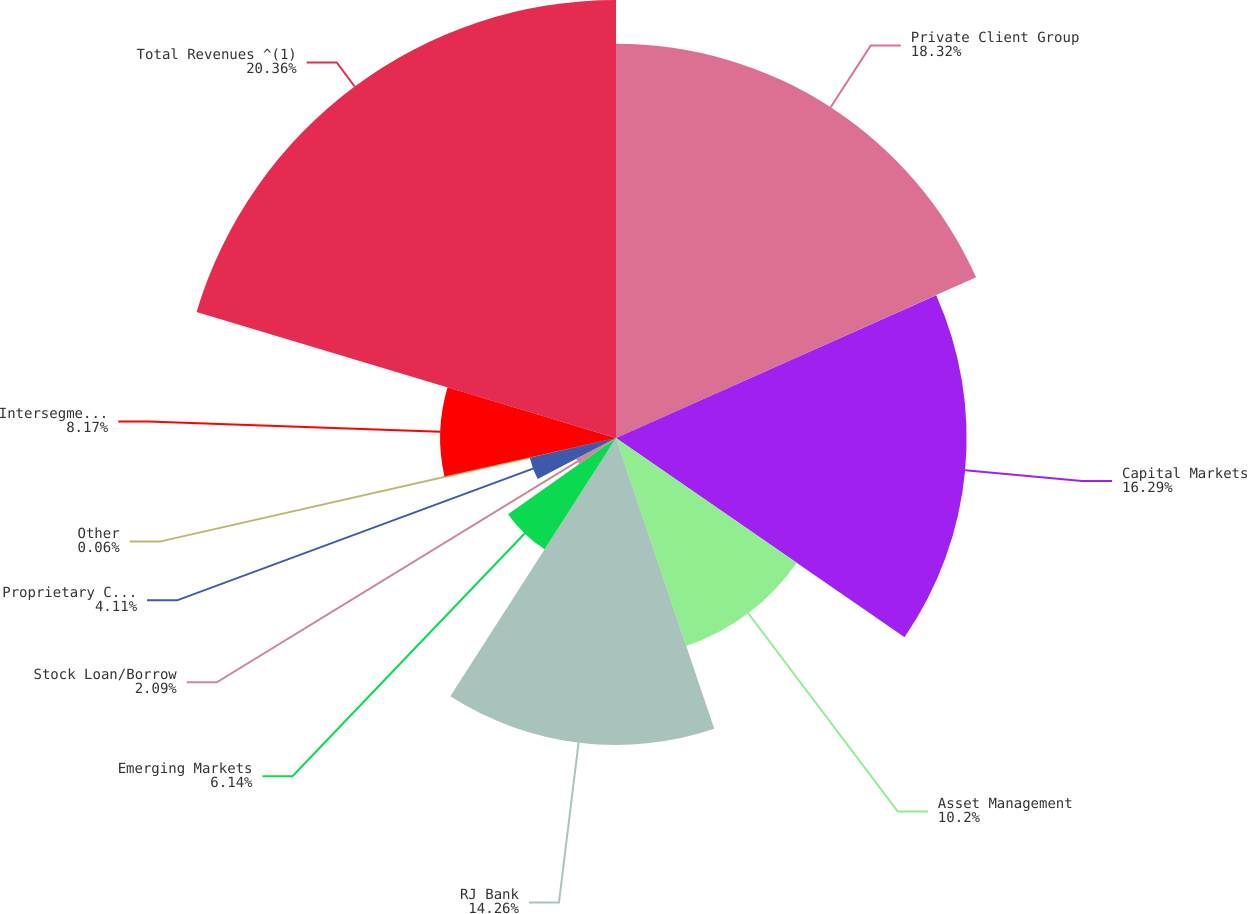Convert chart to OTSL. <chart><loc_0><loc_0><loc_500><loc_500><pie_chart><fcel>Private Client Group<fcel>Capital Markets<fcel>Asset Management<fcel>RJ Bank<fcel>Emerging Markets<fcel>Stock Loan/Borrow<fcel>Proprietary Capital<fcel>Other<fcel>Intersegment Eliminations<fcel>Total Revenues ^(1)<nl><fcel>18.32%<fcel>16.29%<fcel>10.2%<fcel>14.26%<fcel>6.14%<fcel>2.09%<fcel>4.11%<fcel>0.06%<fcel>8.17%<fcel>20.35%<nl></chart> 